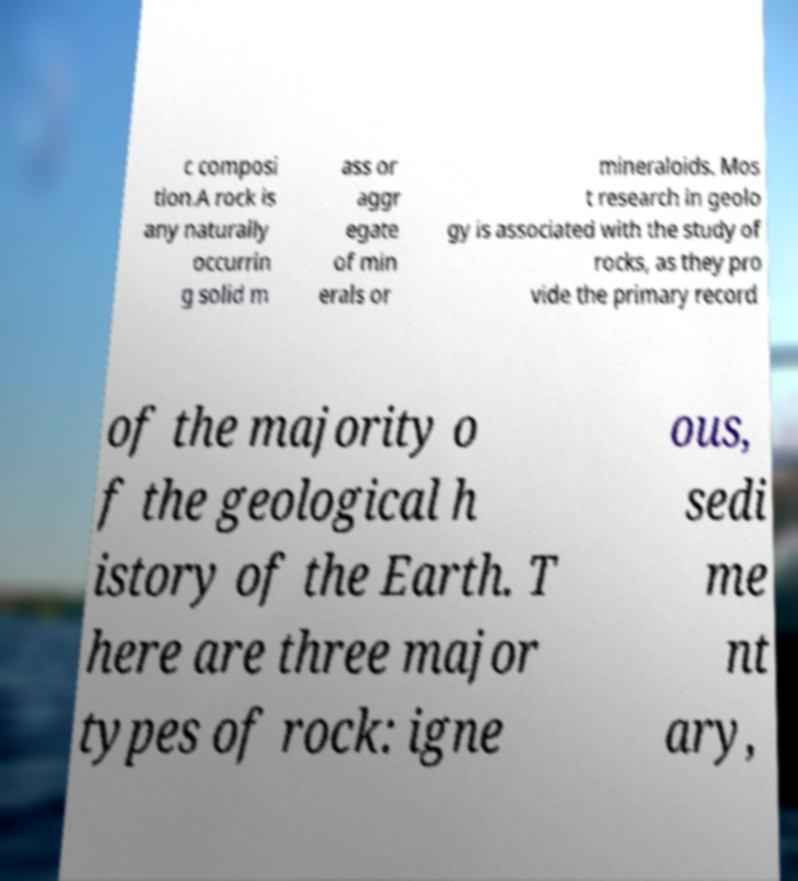I need the written content from this picture converted into text. Can you do that? c composi tion.A rock is any naturally occurrin g solid m ass or aggr egate of min erals or mineraloids. Mos t research in geolo gy is associated with the study of rocks, as they pro vide the primary record of the majority o f the geological h istory of the Earth. T here are three major types of rock: igne ous, sedi me nt ary, 